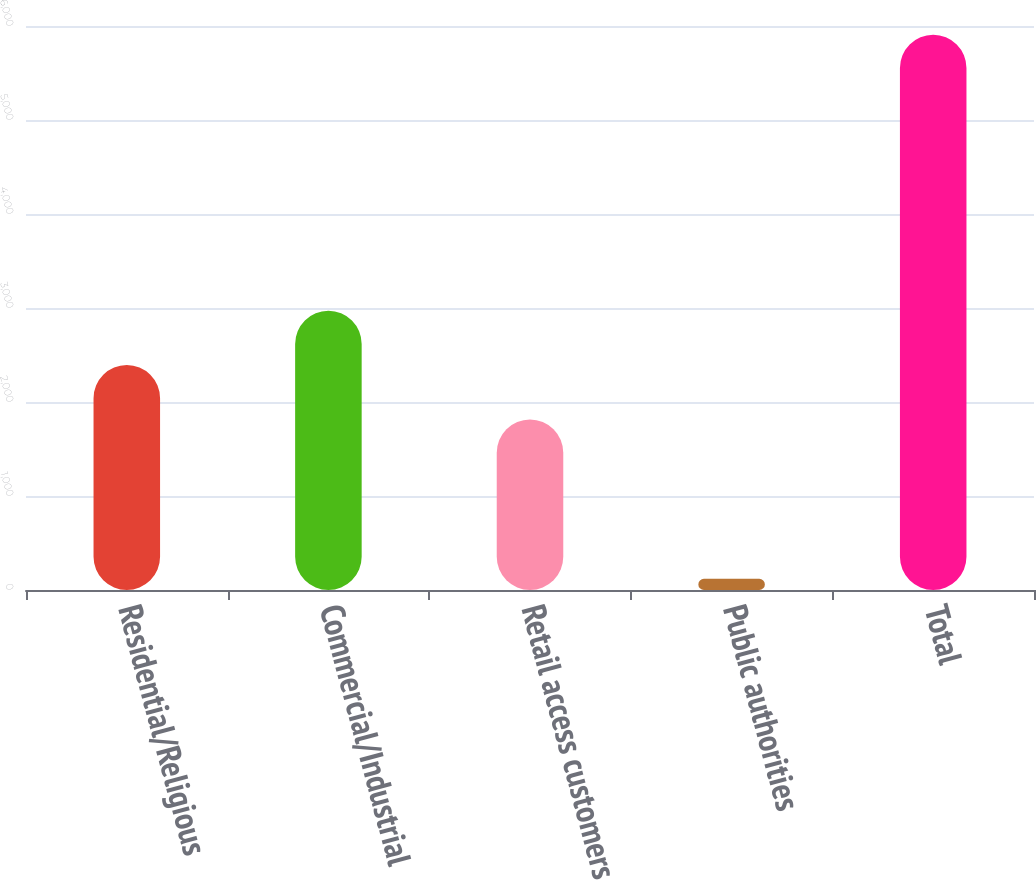Convert chart to OTSL. <chart><loc_0><loc_0><loc_500><loc_500><bar_chart><fcel>Residential/Religious<fcel>Commercial/Industrial<fcel>Retail access customers<fcel>Public authorities<fcel>Total<nl><fcel>2392.8<fcel>2971.6<fcel>1814<fcel>119<fcel>5907<nl></chart> 